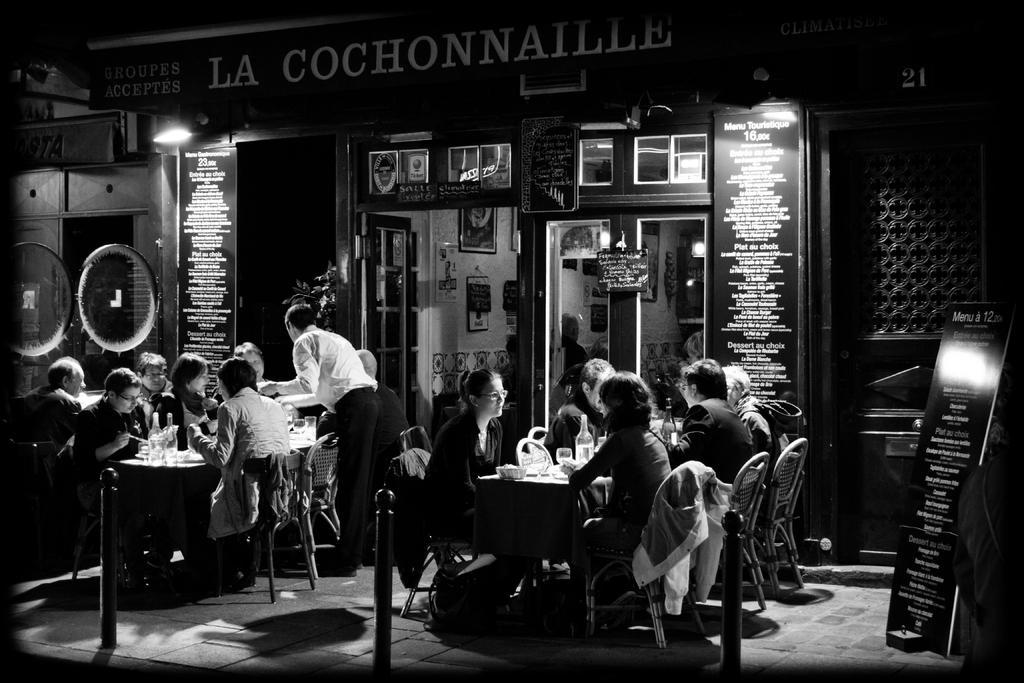Describe this image in one or two sentences. In this picture we can see a group of people on the ground and they are sitting on chairs and one person is standing, here we can see tables, bottles and few objects and in the background we can see the wall, photo frames, boards and some objects. 